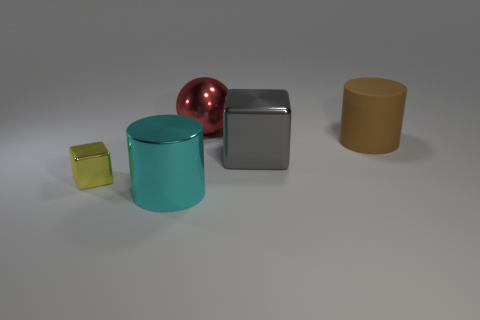How many big cyan metal cylinders are behind the metallic thing right of the large red ball?
Provide a succinct answer. 0. What number of other objects are there of the same material as the small cube?
Your answer should be compact. 3. Are the large object behind the brown rubber cylinder and the big thing right of the big gray metallic cube made of the same material?
Keep it short and to the point. No. Is there any other thing that has the same shape as the brown thing?
Give a very brief answer. Yes. Is the cyan cylinder made of the same material as the big cylinder that is behind the tiny yellow metallic block?
Give a very brief answer. No. What is the color of the shiny cube in front of the shiny object on the right side of the object that is behind the rubber object?
Make the answer very short. Yellow. What shape is the gray metal thing that is the same size as the brown matte cylinder?
Give a very brief answer. Cube. Are there any other things that are the same size as the yellow shiny cube?
Offer a terse response. No. Do the thing in front of the small metal object and the metallic object right of the red thing have the same size?
Your response must be concise. Yes. What is the size of the thing that is behind the brown rubber cylinder?
Offer a terse response. Large. 